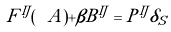Convert formula to latex. <formula><loc_0><loc_0><loc_500><loc_500>F ^ { I J } ( \ A ) + \beta B ^ { I J } = P ^ { I J } \delta _ { S }</formula> 